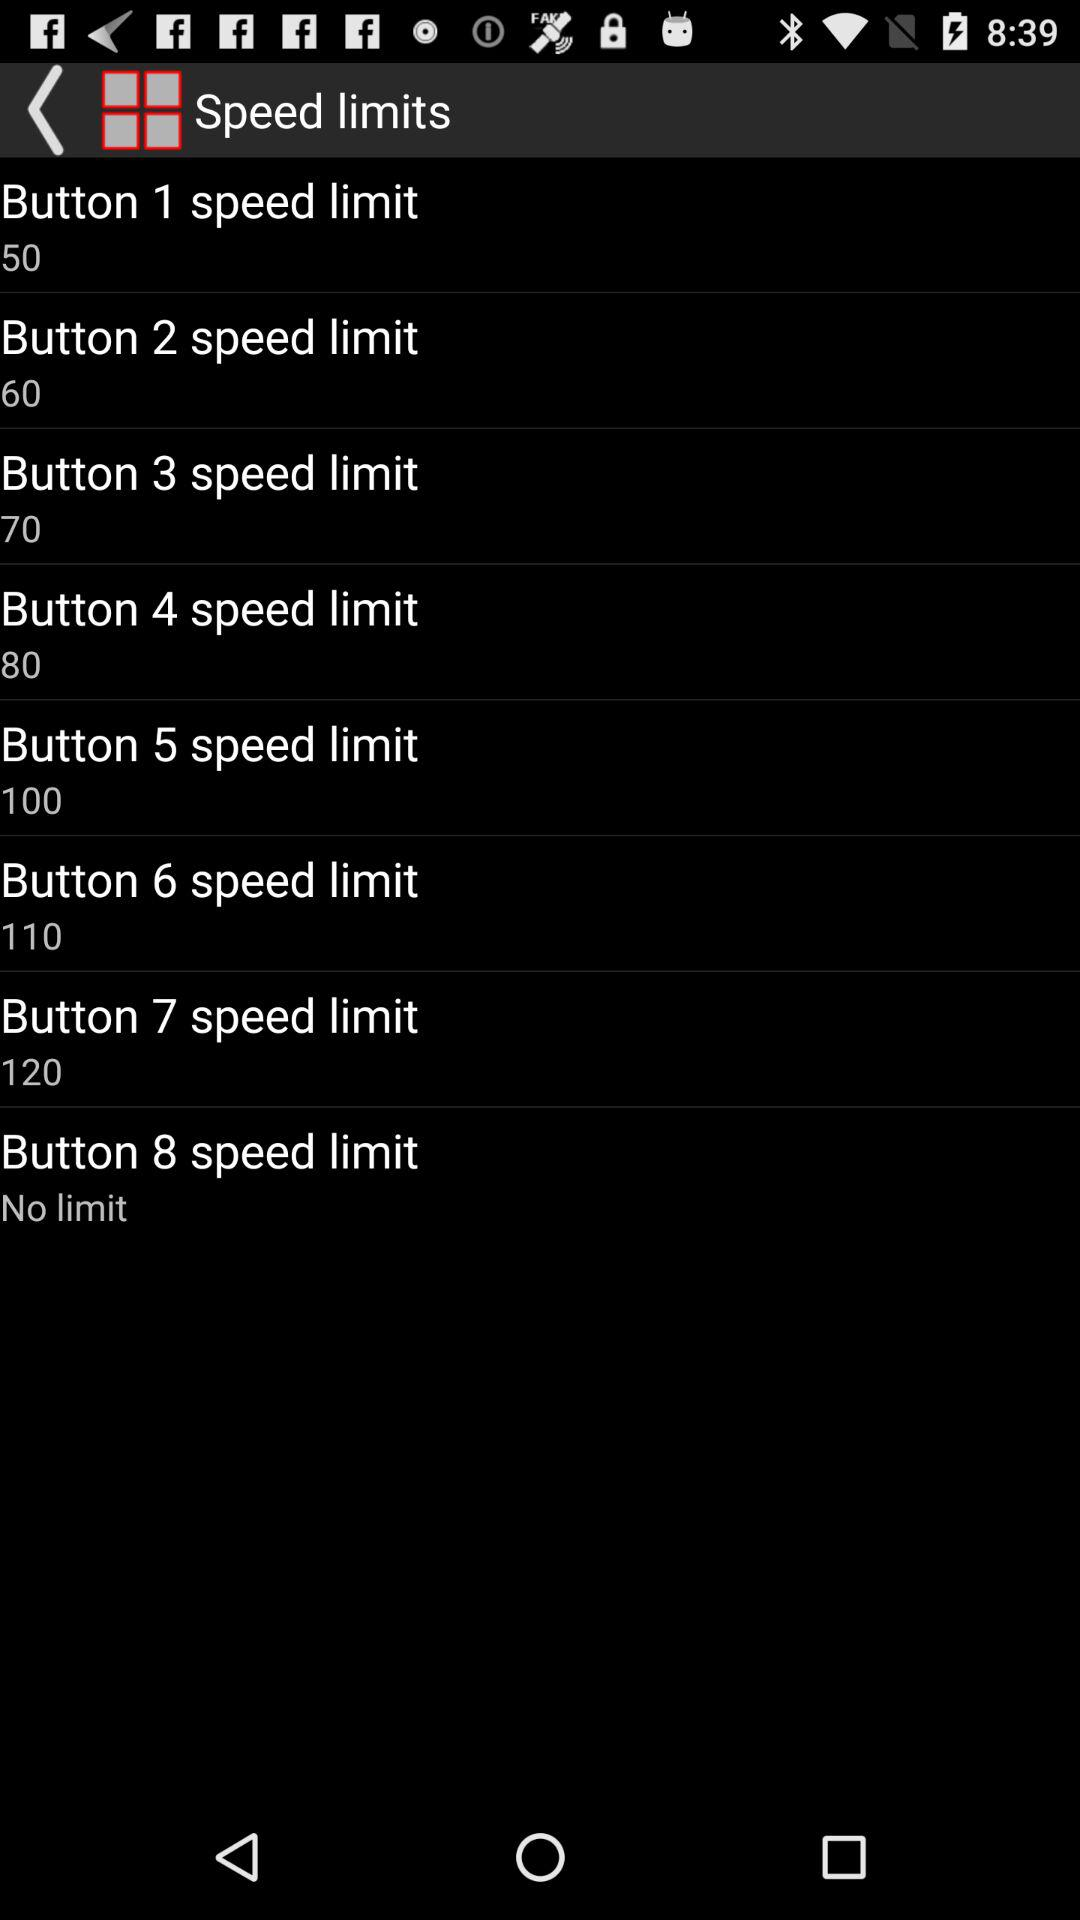What is the speed limit of button 4? The speed limit is 80. 